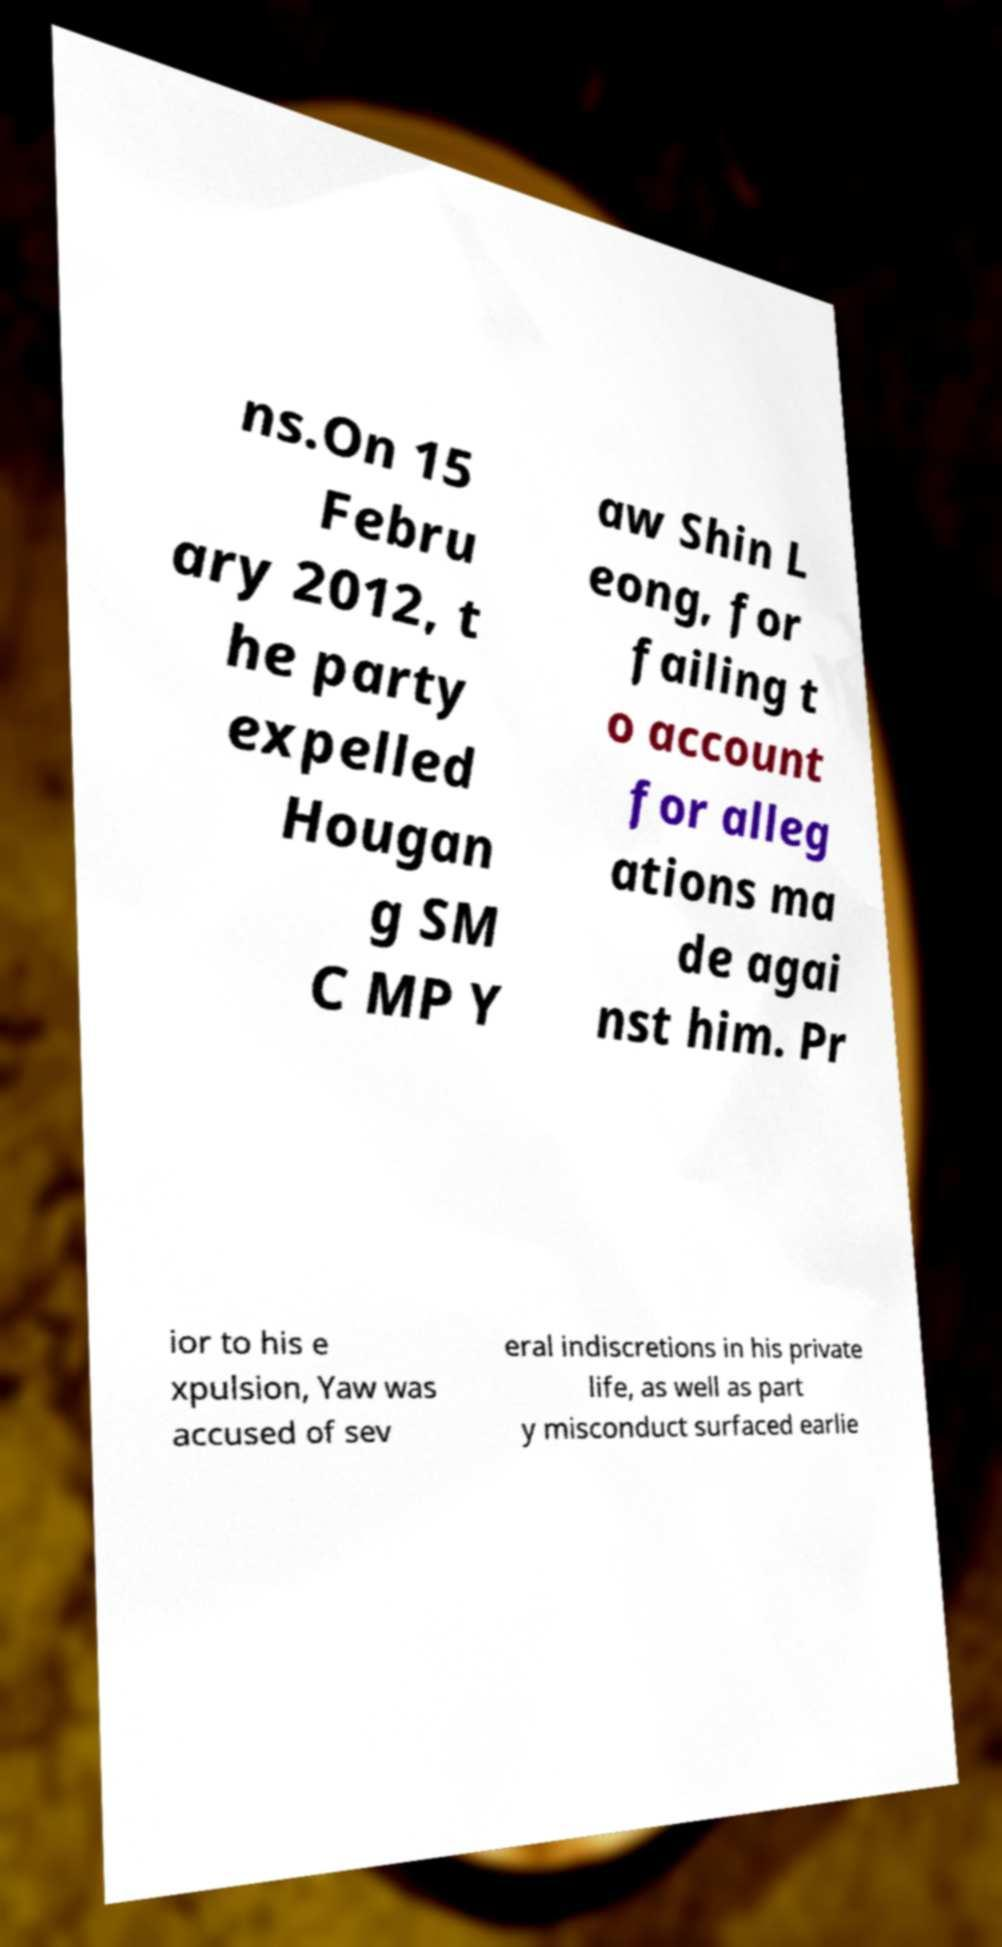Could you assist in decoding the text presented in this image and type it out clearly? ns.On 15 Febru ary 2012, t he party expelled Hougan g SM C MP Y aw Shin L eong, for failing t o account for alleg ations ma de agai nst him. Pr ior to his e xpulsion, Yaw was accused of sev eral indiscretions in his private life, as well as part y misconduct surfaced earlie 